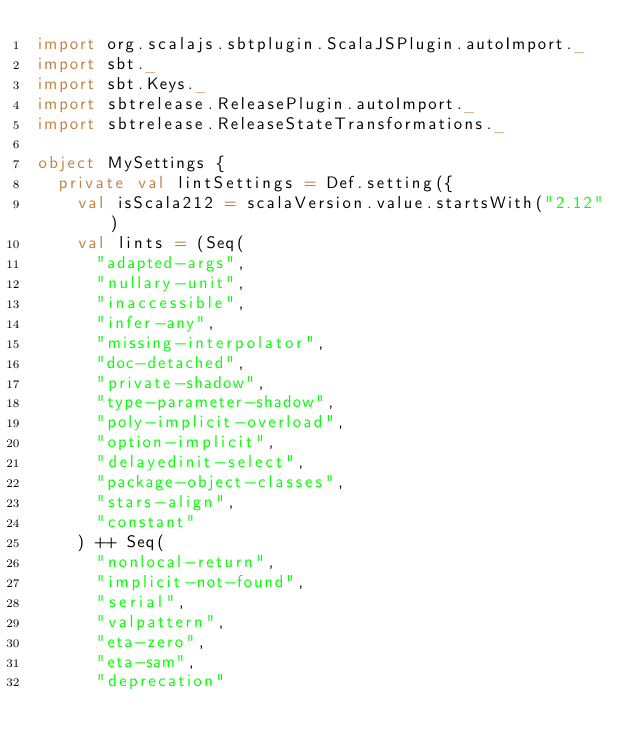<code> <loc_0><loc_0><loc_500><loc_500><_Scala_>import org.scalajs.sbtplugin.ScalaJSPlugin.autoImport._
import sbt._
import sbt.Keys._
import sbtrelease.ReleasePlugin.autoImport._
import sbtrelease.ReleaseStateTransformations._

object MySettings {
  private val lintSettings = Def.setting({
    val isScala212 = scalaVersion.value.startsWith("2.12")
    val lints = (Seq(
      "adapted-args",
      "nullary-unit",
      "inaccessible",
      "infer-any",
      "missing-interpolator",
      "doc-detached",
      "private-shadow",
      "type-parameter-shadow",
      "poly-implicit-overload",
      "option-implicit",
      "delayedinit-select",
      "package-object-classes",
      "stars-align",
      "constant"
    ) ++ Seq(
      "nonlocal-return",
      "implicit-not-found",
      "serial",
      "valpattern",
      "eta-zero",
      "eta-sam",
      "deprecation"</code> 